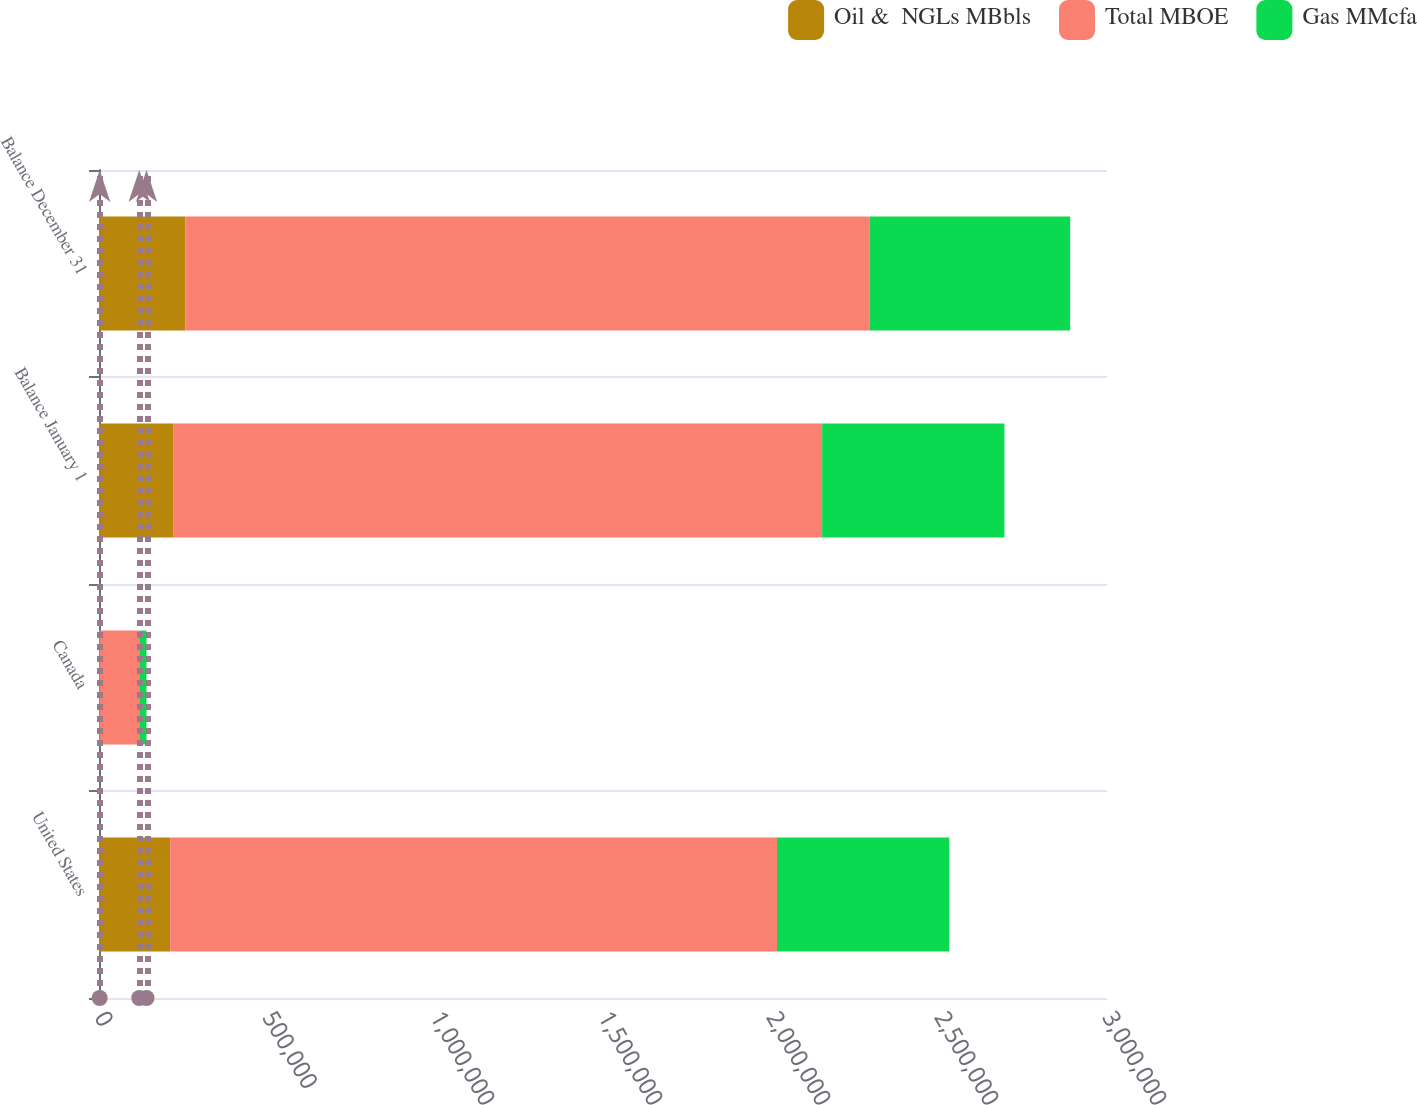Convert chart to OTSL. <chart><loc_0><loc_0><loc_500><loc_500><stacked_bar_chart><ecel><fcel>United States<fcel>Canada<fcel>Balance January 1<fcel>Balance December 31<nl><fcel>Oil &  NGLs MBbls<fcel>211814<fcel>2053<fcel>220666<fcel>256679<nl><fcel>Total MBOE<fcel>1.80597e+06<fcel>117672<fcel>1.93149e+06<fcel>2.03744e+06<nl><fcel>Gas MMcfa<fcel>512809<fcel>21665<fcel>542581<fcel>596253<nl></chart> 